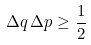Convert formula to latex. <formula><loc_0><loc_0><loc_500><loc_500>\Delta q \, \Delta p \geq \frac { 1 } { 2 }</formula> 